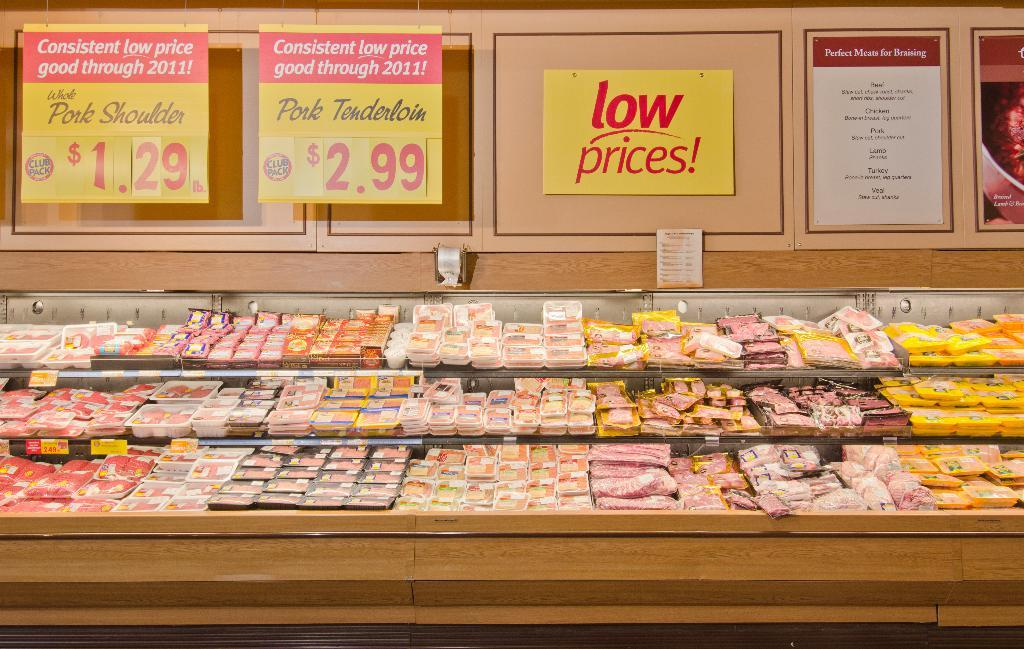<image>
Give a short and clear explanation of the subsequent image. In this section of the grocery store one can purchase Pork Tenderloin at $2.99. 